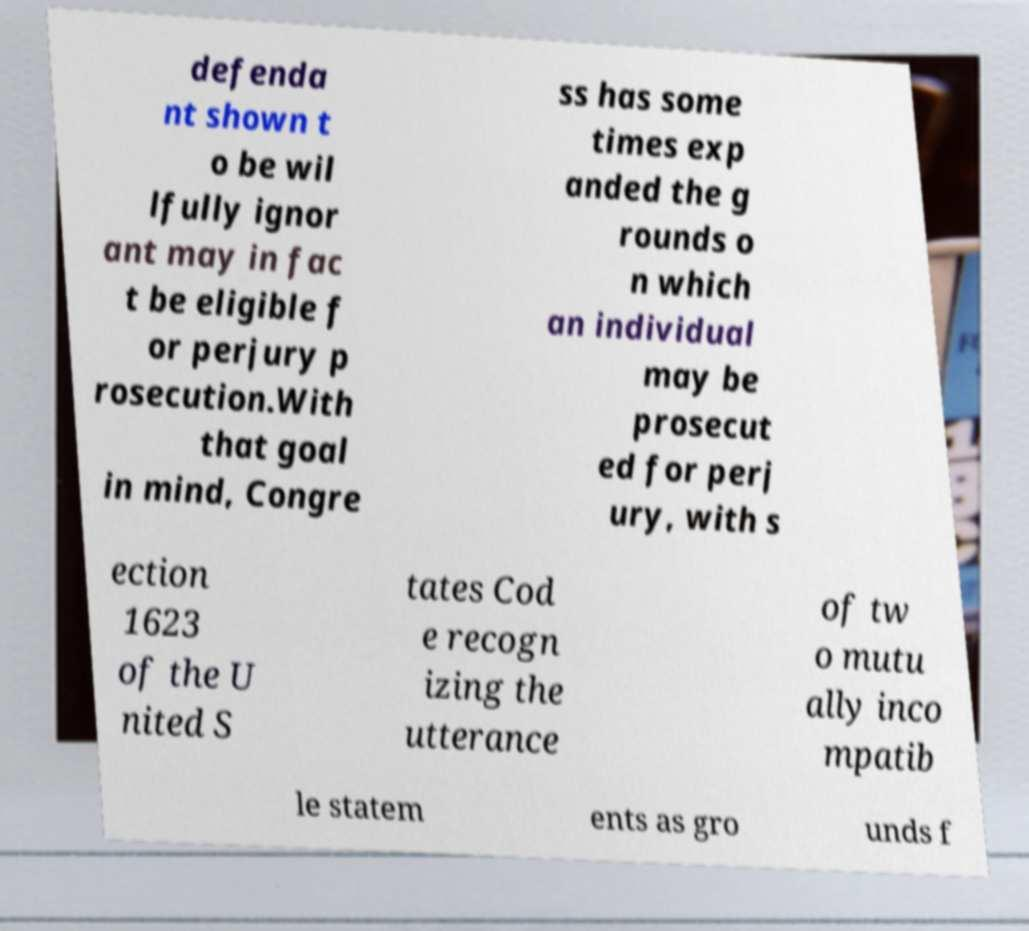Please identify and transcribe the text found in this image. defenda nt shown t o be wil lfully ignor ant may in fac t be eligible f or perjury p rosecution.With that goal in mind, Congre ss has some times exp anded the g rounds o n which an individual may be prosecut ed for perj ury, with s ection 1623 of the U nited S tates Cod e recogn izing the utterance of tw o mutu ally inco mpatib le statem ents as gro unds f 